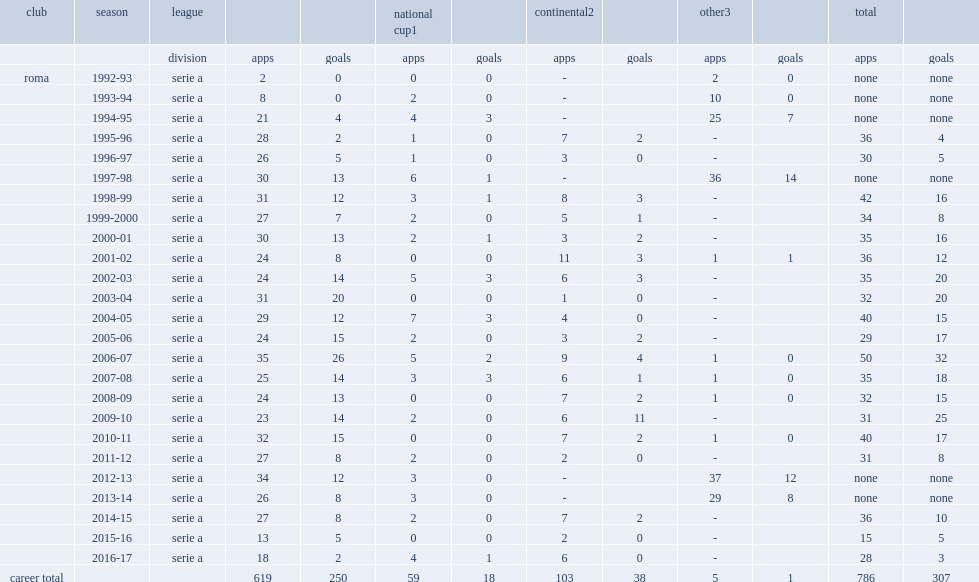Which club did francesco totti appear in the league, in 2015-16 serie a season? Roma. 